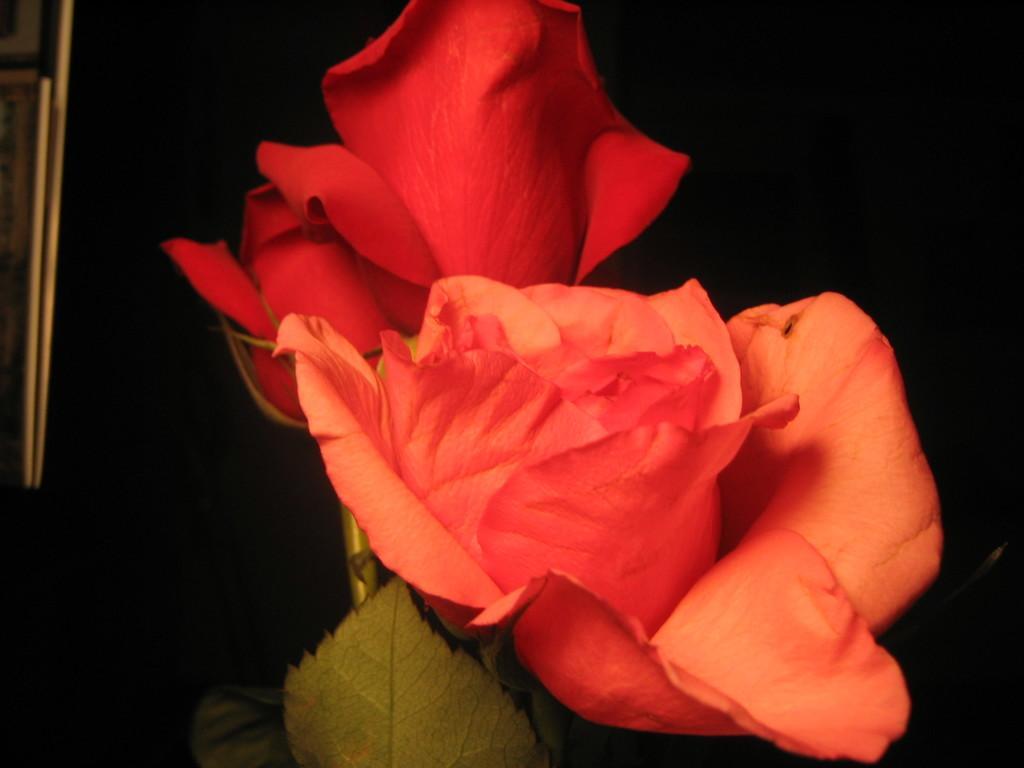Please provide a concise description of this image. There are flowers in the center of the image, it seems like a frame on the left side and the background is dark. 